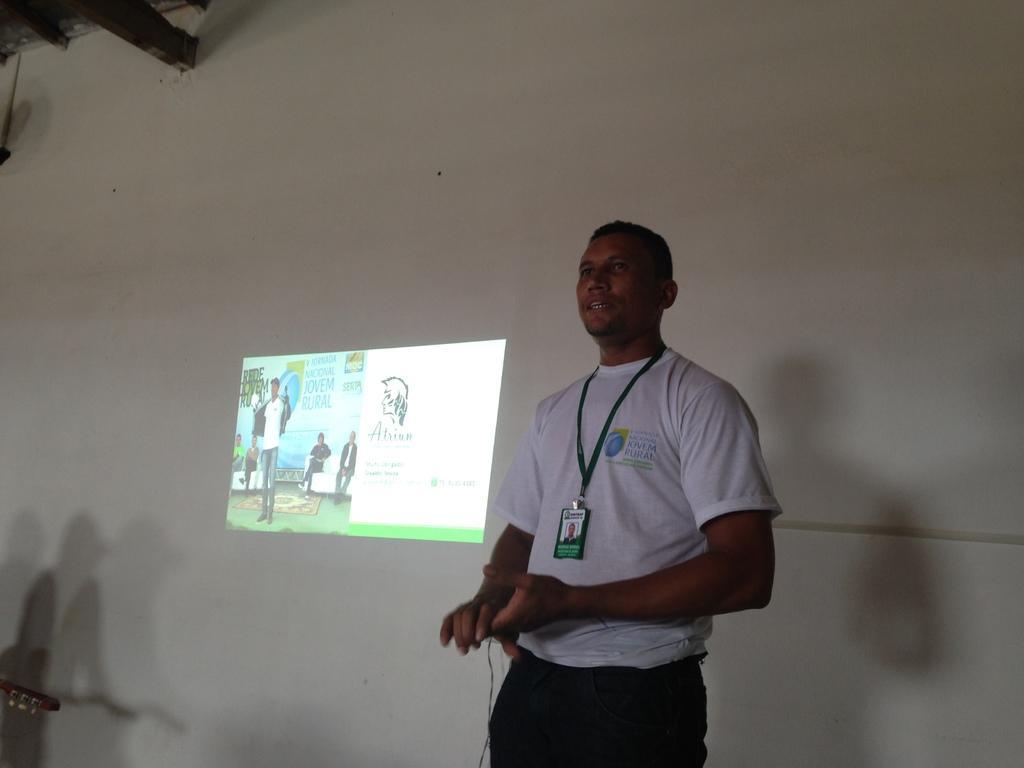Please provide a concise description of this image. In this picture there is a man who is wearing white t-shirt and black trouser. He is standing near to the projector screen. In the top left corner I can see the woods. In the projector screen I can see some people who are sitting on the couch. 